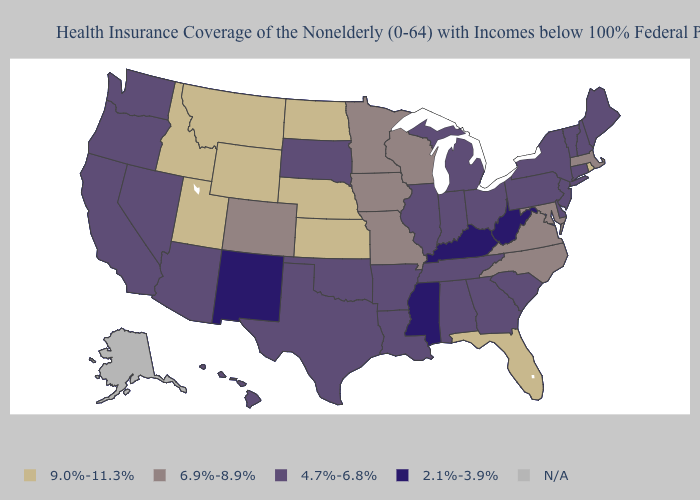What is the value of Florida?
Be succinct. 9.0%-11.3%. What is the lowest value in states that border Vermont?
Give a very brief answer. 4.7%-6.8%. Which states have the lowest value in the West?
Short answer required. New Mexico. What is the value of Virginia?
Concise answer only. 6.9%-8.9%. What is the highest value in states that border Washington?
Concise answer only. 9.0%-11.3%. Which states have the highest value in the USA?
Write a very short answer. Florida, Idaho, Kansas, Montana, Nebraska, North Dakota, Rhode Island, Utah, Wyoming. What is the lowest value in the USA?
Short answer required. 2.1%-3.9%. What is the value of New Mexico?
Be succinct. 2.1%-3.9%. Which states have the highest value in the USA?
Answer briefly. Florida, Idaho, Kansas, Montana, Nebraska, North Dakota, Rhode Island, Utah, Wyoming. Among the states that border Connecticut , which have the highest value?
Short answer required. Rhode Island. What is the lowest value in the USA?
Be succinct. 2.1%-3.9%. What is the highest value in the USA?
Keep it brief. 9.0%-11.3%. Which states have the highest value in the USA?
Give a very brief answer. Florida, Idaho, Kansas, Montana, Nebraska, North Dakota, Rhode Island, Utah, Wyoming. What is the lowest value in the USA?
Answer briefly. 2.1%-3.9%. What is the lowest value in states that border Idaho?
Write a very short answer. 4.7%-6.8%. 